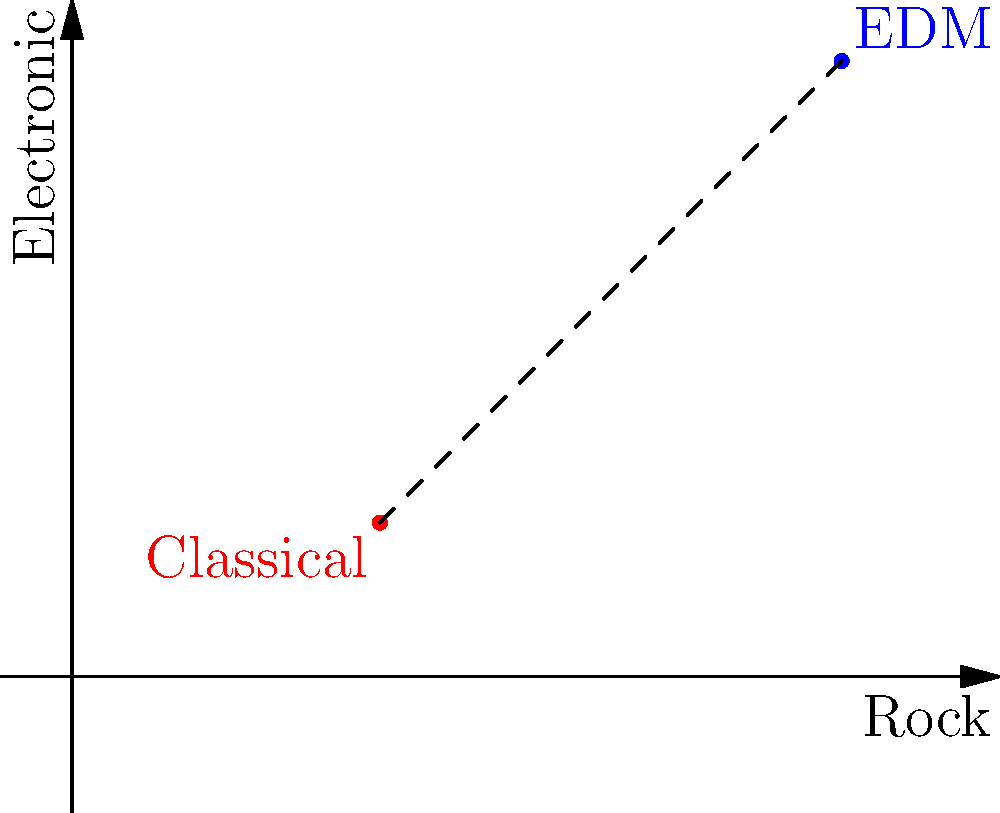On a coordinate plane representing different music genres, Classical music is located at point (2,1) and Electronic Dance Music (EDM) is at point (5,4). As a parent exploring your college student's new music tastes, calculate the distance between these two genres using the distance formula. Round your answer to two decimal places. To find the distance between two points on a coordinate plane, we use the distance formula:

$$d = \sqrt{(x_2 - x_1)^2 + (y_2 - y_1)^2}$$

Where $(x_1, y_1)$ is the first point and $(x_2, y_2)$ is the second point.

In this case:
Classical: $(x_1, y_1) = (2, 1)$
EDM: $(x_2, y_2) = (5, 4)$

Let's substitute these values into the formula:

$$d = \sqrt{(5 - 2)^2 + (4 - 1)^2}$$

Simplify:
$$d = \sqrt{3^2 + 3^2}$$
$$d = \sqrt{9 + 9}$$
$$d = \sqrt{18}$$

Calculate the square root:
$$d \approx 4.2426$$

Rounding to two decimal places:
$$d \approx 4.24$$

This distance represents the musical "gap" between Classical and EDM genres, which you're bridging as you explore your child's new music interests.
Answer: 4.24 units 